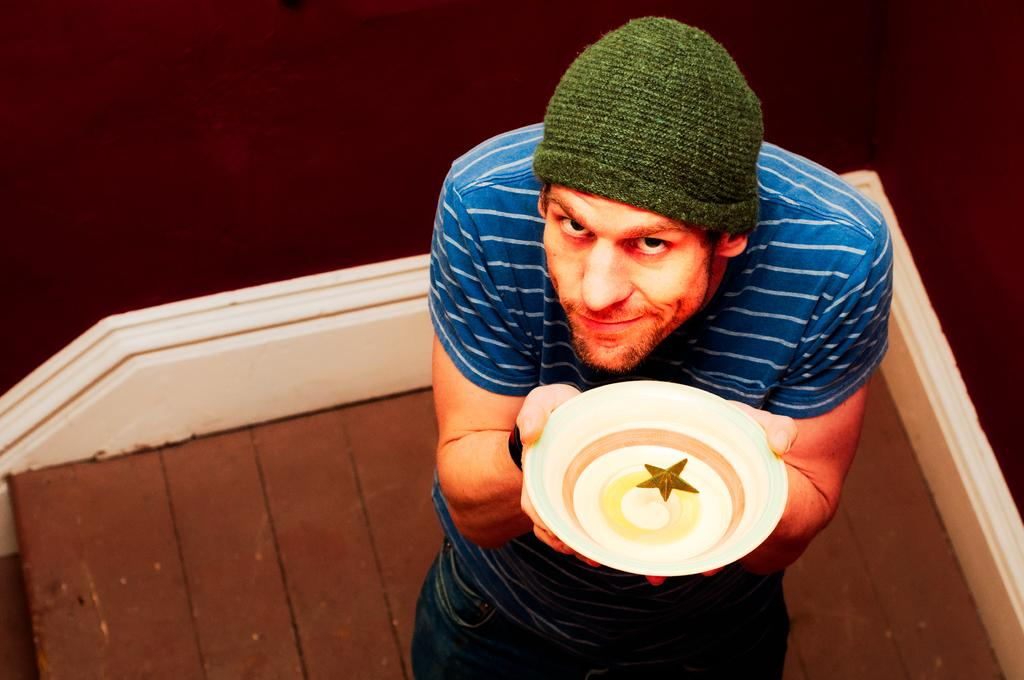What is the main subject of the image? There is a person in the image. What is the person wearing on their upper body? The person is wearing a blue T-shirt. What type of headwear is the person wearing? The person is wearing a green cap. What object is the person holding in the image? The person is holding a white plate. What can be seen in the background of the image? There is a wall in the background of the image. Is the person's sister saying good-bye to them in the image? There is no indication of a sister or any good-bye in the image; it only shows a person holding a white plate. Can you see any sand in the image? There is no sand present in the image. 